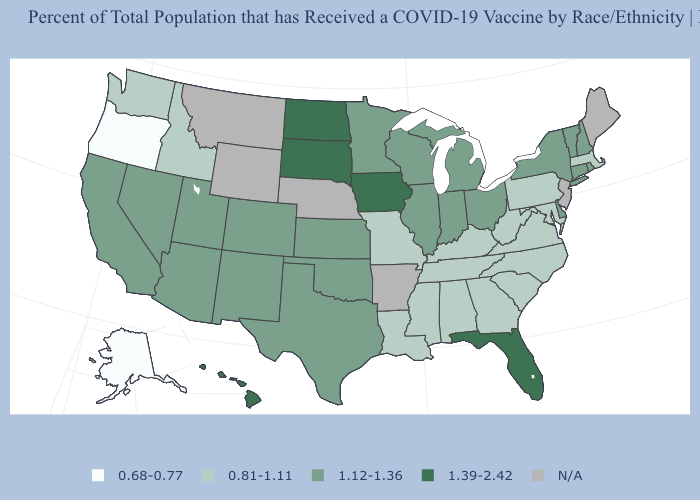Which states have the lowest value in the USA?
Quick response, please. Alaska, Oregon. What is the value of Washington?
Give a very brief answer. 0.81-1.11. What is the value of Florida?
Give a very brief answer. 1.39-2.42. What is the value of Idaho?
Give a very brief answer. 0.81-1.11. What is the lowest value in states that border Massachusetts?
Answer briefly. 1.12-1.36. Name the states that have a value in the range N/A?
Answer briefly. Arkansas, Maine, Montana, Nebraska, New Jersey, Wyoming. Name the states that have a value in the range 0.68-0.77?
Be succinct. Alaska, Oregon. Name the states that have a value in the range 1.12-1.36?
Give a very brief answer. Arizona, California, Colorado, Connecticut, Delaware, Illinois, Indiana, Kansas, Michigan, Minnesota, Nevada, New Hampshire, New Mexico, New York, Ohio, Oklahoma, Rhode Island, Texas, Utah, Vermont, Wisconsin. What is the highest value in the South ?
Be succinct. 1.39-2.42. Which states have the lowest value in the South?
Keep it brief. Alabama, Georgia, Kentucky, Louisiana, Maryland, Mississippi, North Carolina, South Carolina, Tennessee, Virginia, West Virginia. Name the states that have a value in the range N/A?
Be succinct. Arkansas, Maine, Montana, Nebraska, New Jersey, Wyoming. How many symbols are there in the legend?
Keep it brief. 5. What is the value of Texas?
Give a very brief answer. 1.12-1.36. 